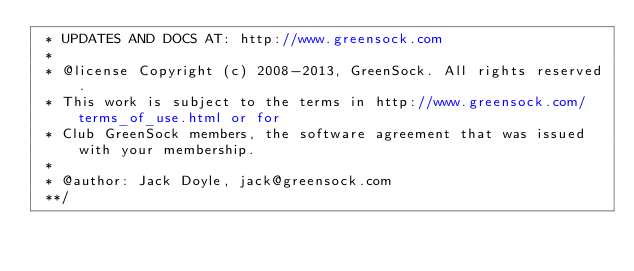Convert code to text. <code><loc_0><loc_0><loc_500><loc_500><_JavaScript_> * UPDATES AND DOCS AT: http://www.greensock.com
 *
 * @license Copyright (c) 2008-2013, GreenSock. All rights reserved.
 * This work is subject to the terms in http://www.greensock.com/terms_of_use.html or for 
 * Club GreenSock members, the software agreement that was issued with your membership.
 * 
 * @author: Jack Doyle, jack@greensock.com
 **/</code> 